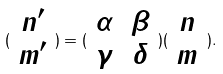<formula> <loc_0><loc_0><loc_500><loc_500>( \begin{array} { c } n ^ { \prime } \\ m ^ { \prime } \end{array} ) = ( \begin{array} { c c } \alpha & \beta \\ \gamma & \delta \end{array} ) ( \begin{array} { c } n \\ m \end{array} ) .</formula> 